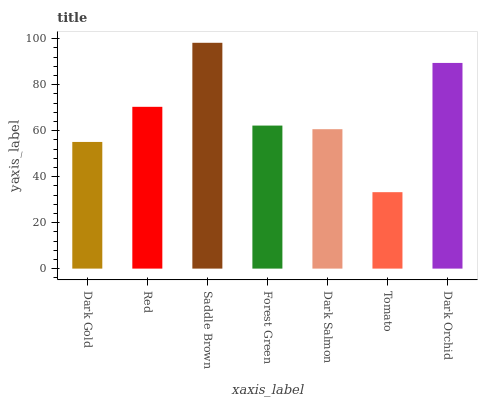Is Red the minimum?
Answer yes or no. No. Is Red the maximum?
Answer yes or no. No. Is Red greater than Dark Gold?
Answer yes or no. Yes. Is Dark Gold less than Red?
Answer yes or no. Yes. Is Dark Gold greater than Red?
Answer yes or no. No. Is Red less than Dark Gold?
Answer yes or no. No. Is Forest Green the high median?
Answer yes or no. Yes. Is Forest Green the low median?
Answer yes or no. Yes. Is Dark Gold the high median?
Answer yes or no. No. Is Dark Orchid the low median?
Answer yes or no. No. 